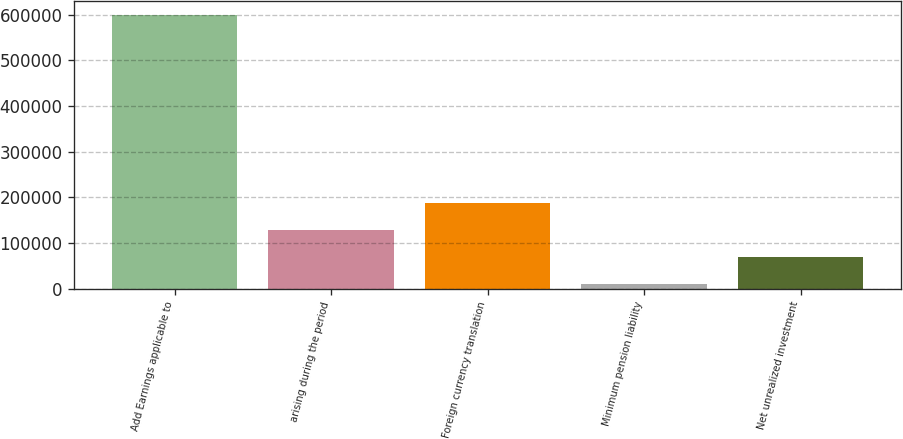Convert chart. <chart><loc_0><loc_0><loc_500><loc_500><bar_chart><fcel>Add Earnings applicable to<fcel>arising during the period<fcel>Foreign currency translation<fcel>Minimum pension liability<fcel>Net unrealized investment<nl><fcel>599360<fcel>128263<fcel>187150<fcel>10489<fcel>69376.1<nl></chart> 